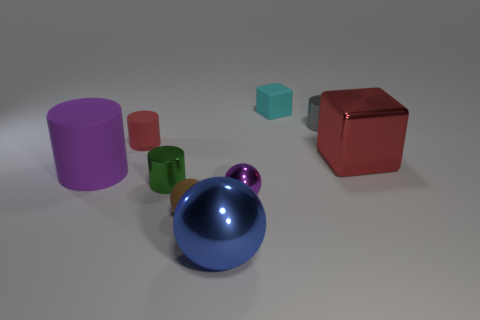Add 1 big yellow rubber things. How many objects exist? 10 Subtract all spheres. How many objects are left? 6 Add 3 blue shiny balls. How many blue shiny balls exist? 4 Subtract 0 brown cylinders. How many objects are left? 9 Subtract all small green shiny blocks. Subtract all tiny green things. How many objects are left? 8 Add 2 small purple objects. How many small purple objects are left? 3 